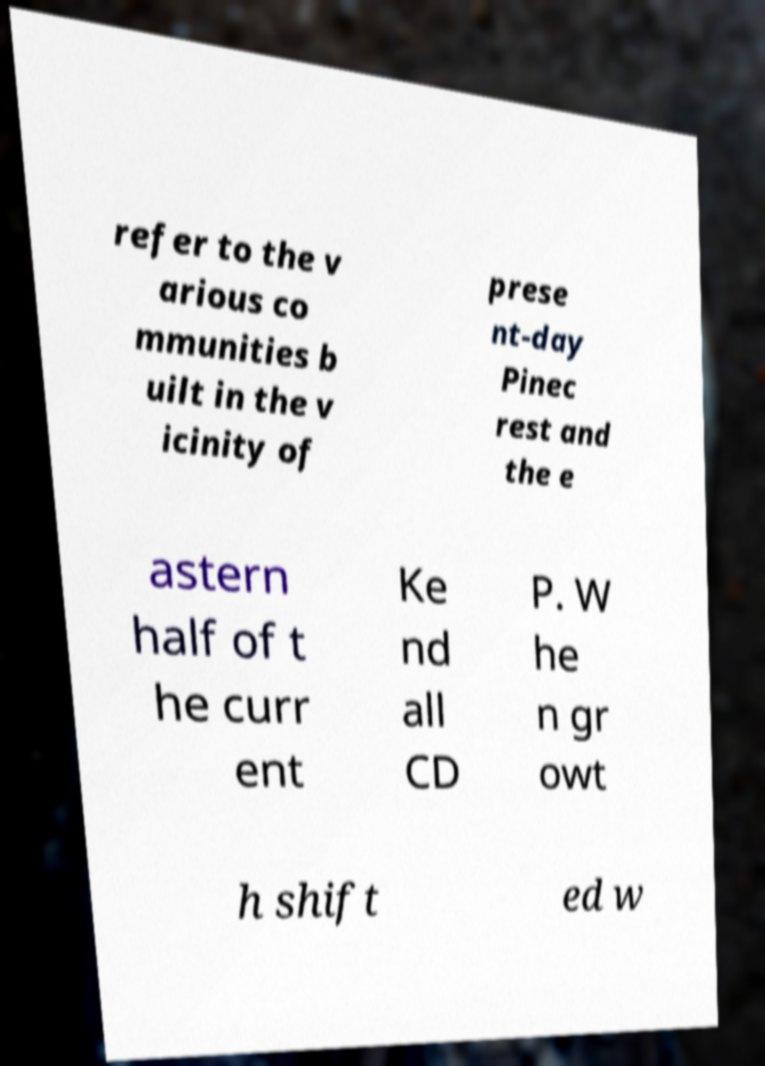Can you read and provide the text displayed in the image?This photo seems to have some interesting text. Can you extract and type it out for me? refer to the v arious co mmunities b uilt in the v icinity of prese nt-day Pinec rest and the e astern half of t he curr ent Ke nd all CD P. W he n gr owt h shift ed w 